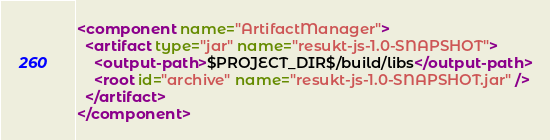Convert code to text. <code><loc_0><loc_0><loc_500><loc_500><_XML_><component name="ArtifactManager">
  <artifact type="jar" name="resukt-js-1.0-SNAPSHOT">
    <output-path>$PROJECT_DIR$/build/libs</output-path>
    <root id="archive" name="resukt-js-1.0-SNAPSHOT.jar" />
  </artifact>
</component></code> 